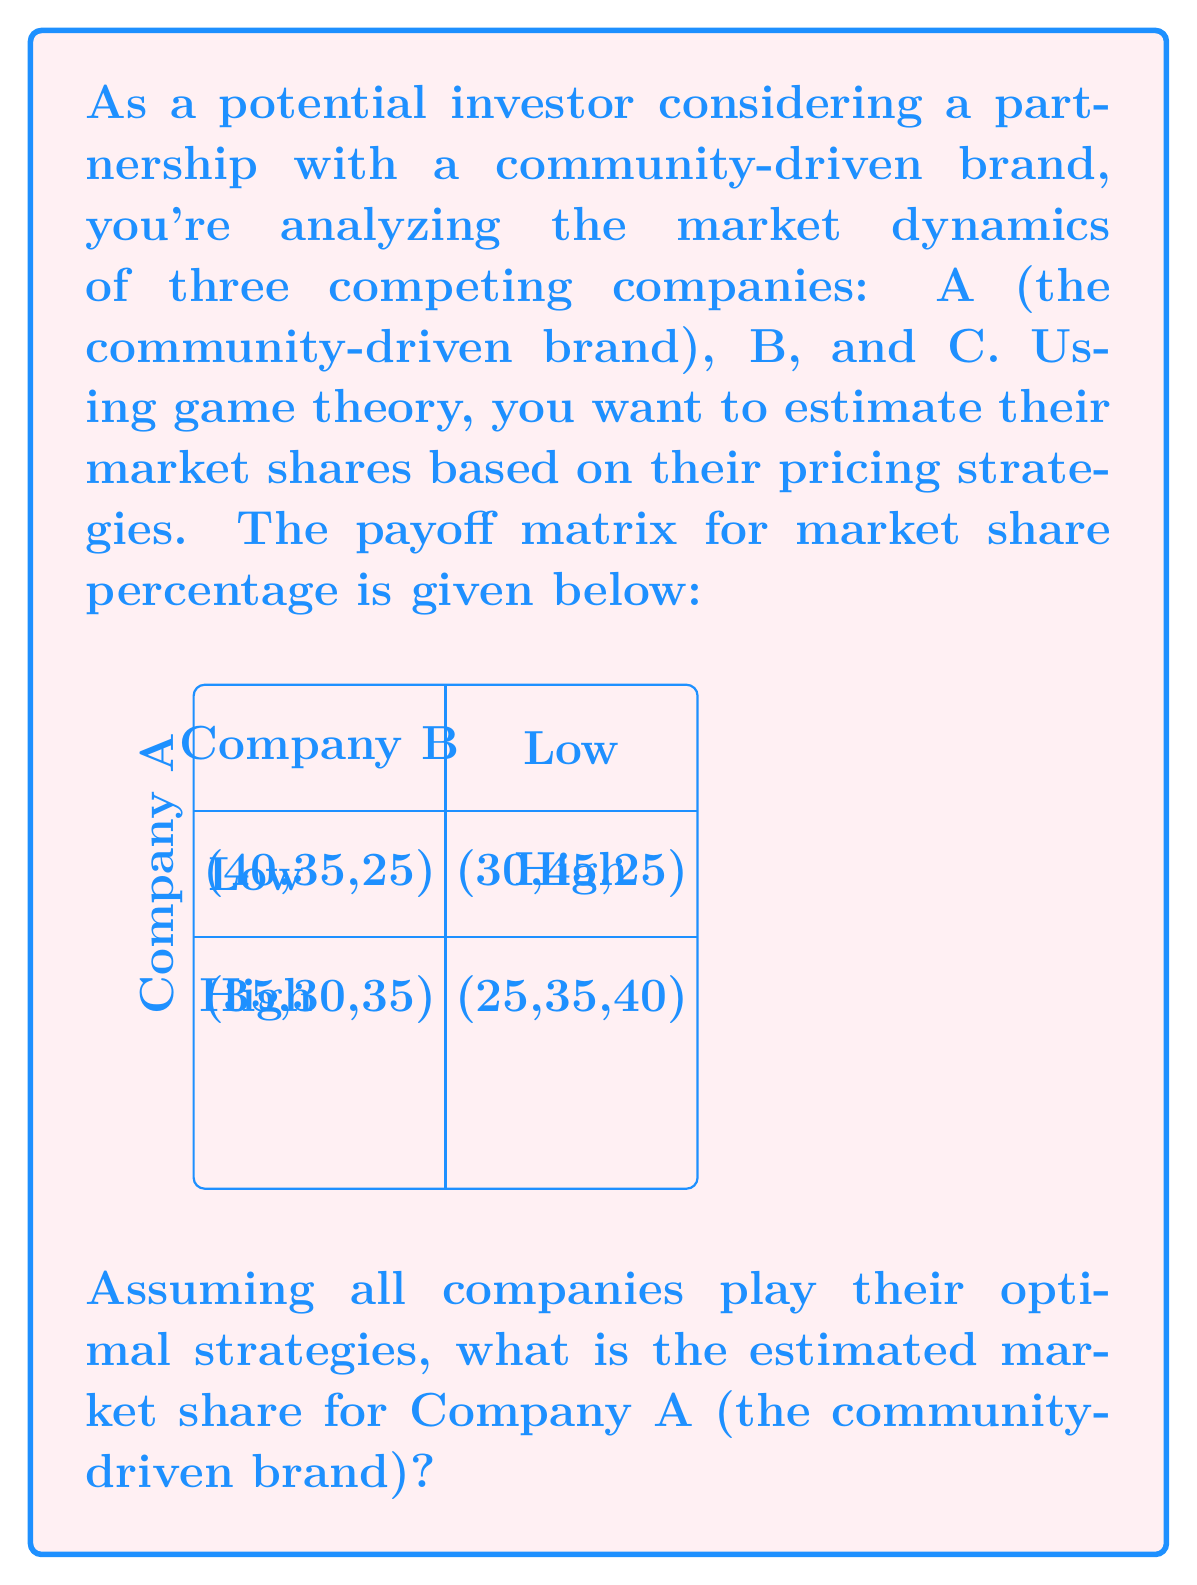Provide a solution to this math problem. To solve this problem, we'll use the concept of Nash equilibrium from game theory. Here's the step-by-step approach:

1) First, we need to identify the Nash equilibrium in this game. A Nash equilibrium occurs when no player can unilaterally improve their outcome by changing their strategy.

2) Let's analyze Company A's strategies:
   - If B chooses "Low", A gets 40% with "Low" and 35% with "High"
   - If B chooses "High", A gets 30% with "Low" and 25% with "High"
   In both cases, A's best response is "Low"

3) Now, let's analyze Company B's strategies:
   - If A chooses "Low", B gets 35% with "Low" and 45% with "High"
   - If A chooses "High", B gets 30% with "Low" and 35% with "High"
   In both cases, B's best response is "High"

4) The Nash equilibrium is therefore (Low, High), resulting in market shares of (30%, 45%, 25%) for companies A, B, and C respectively.

5) To calculate the mixed strategy equilibrium, let's define:
   $p$ = probability of A choosing "Low"
   $q$ = probability of B choosing "Low"

6) For A to be indifferent between strategies:
   $40q + 30(1-q) = 35q + 25(1-q)$
   $10q + 30 = 10q + 25$
   $30 = 25$
   This equation has no solution, confirming there's no mixed strategy equilibrium.

7) Therefore, the pure strategy Nash equilibrium (Low, High) is the only equilibrium, and Company A's estimated market share is 30%.
Answer: 30% 